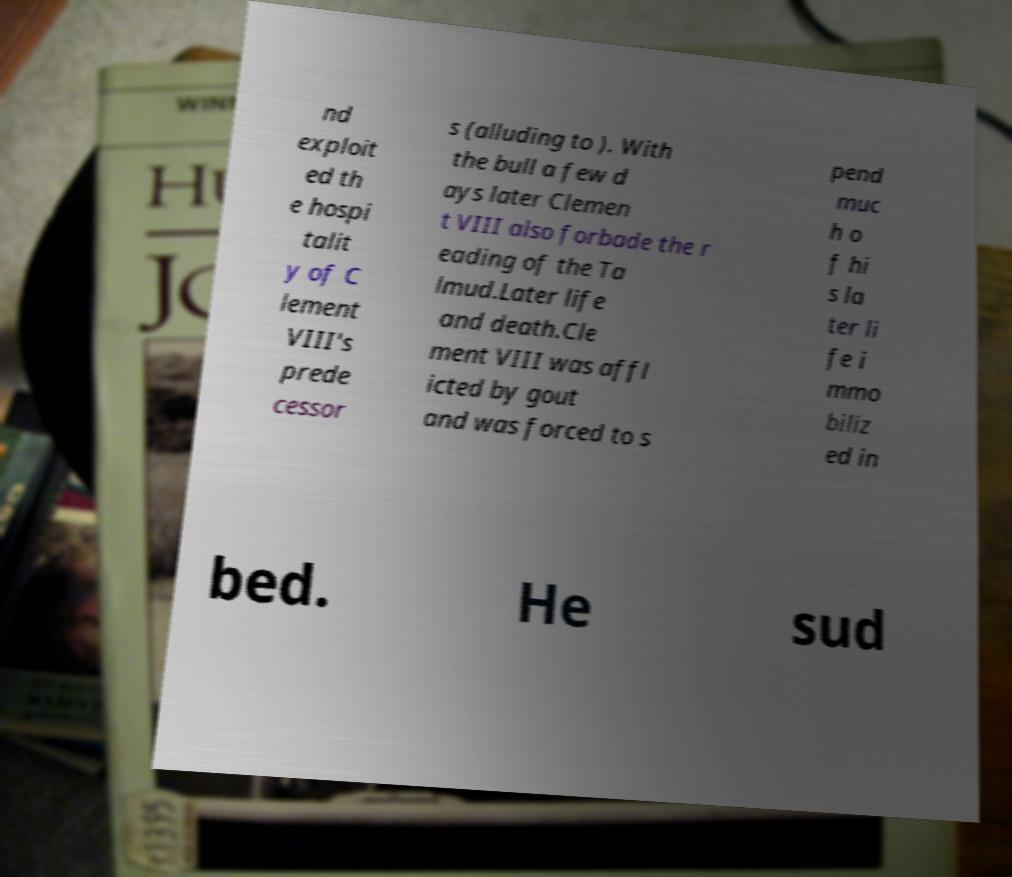Could you assist in decoding the text presented in this image and type it out clearly? nd exploit ed th e hospi talit y of C lement VIII's prede cessor s (alluding to ). With the bull a few d ays later Clemen t VIII also forbade the r eading of the Ta lmud.Later life and death.Cle ment VIII was affl icted by gout and was forced to s pend muc h o f hi s la ter li fe i mmo biliz ed in bed. He sud 